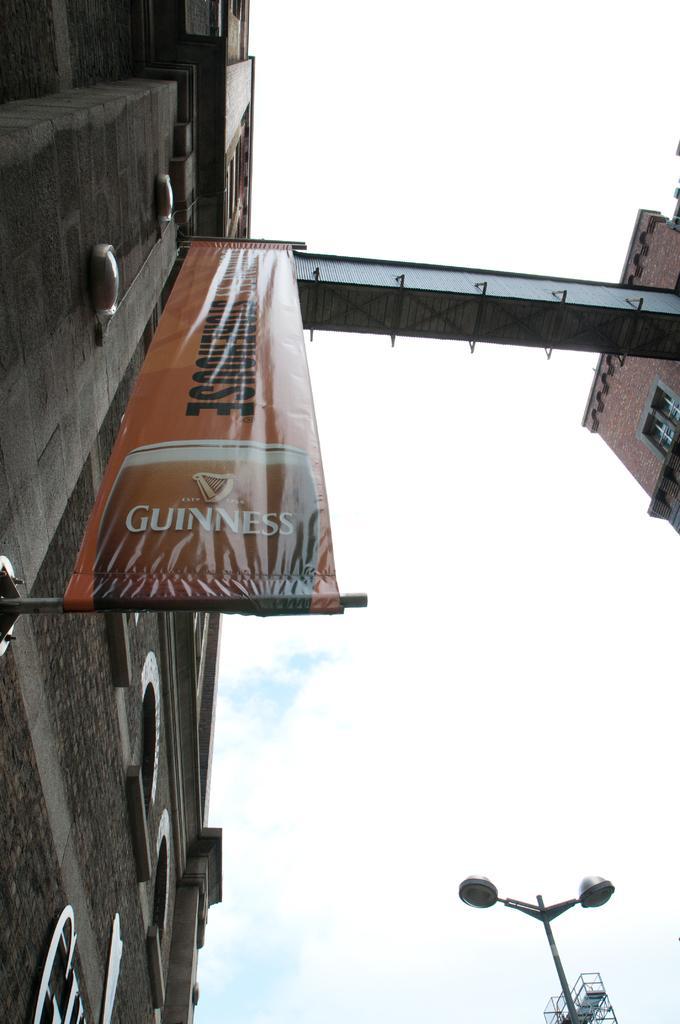Could you give a brief overview of what you see in this image? In this picture we can see a building with windows, banner, pole, lights and in the background we can see the sky with clouds. 